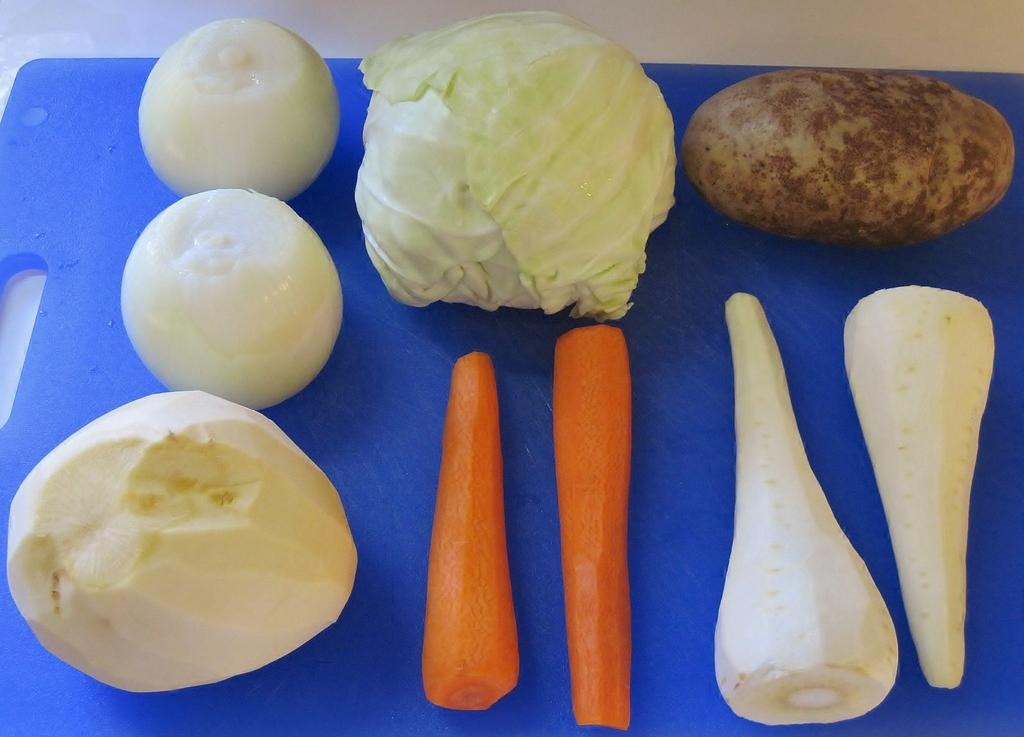How many carrots are in the image? There are two carrots in the image. How many radishes are in the image? There are two radishes in the image. How many potatoes are in the image? There is one potato in the image. How many cabbages are in the image? There is one cabbage in the image. How many white onions are in the image? There are two white onions in the image. What else can be seen on the chopping board in the image? There are other vegetables on a chopping board in the image. What type of horn can be seen on the vegetables in the image? There are no horns present on the vegetables in the image. What time is depicted in the image? The image does not depict a specific hour or time of day. 